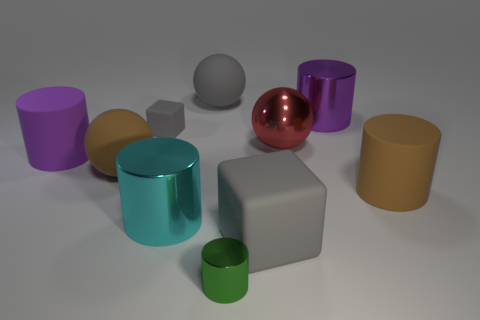Subtract all brown rubber balls. How many balls are left? 2 Subtract 2 cubes. How many cubes are left? 0 Subtract all gray balls. How many balls are left? 2 Subtract all gray cubes. How many purple cylinders are left? 2 Subtract 1 purple cylinders. How many objects are left? 9 Subtract all cubes. How many objects are left? 8 Subtract all red spheres. Subtract all cyan blocks. How many spheres are left? 2 Subtract all tiny brown metallic spheres. Subtract all big red balls. How many objects are left? 9 Add 1 rubber spheres. How many rubber spheres are left? 3 Add 2 metal things. How many metal things exist? 6 